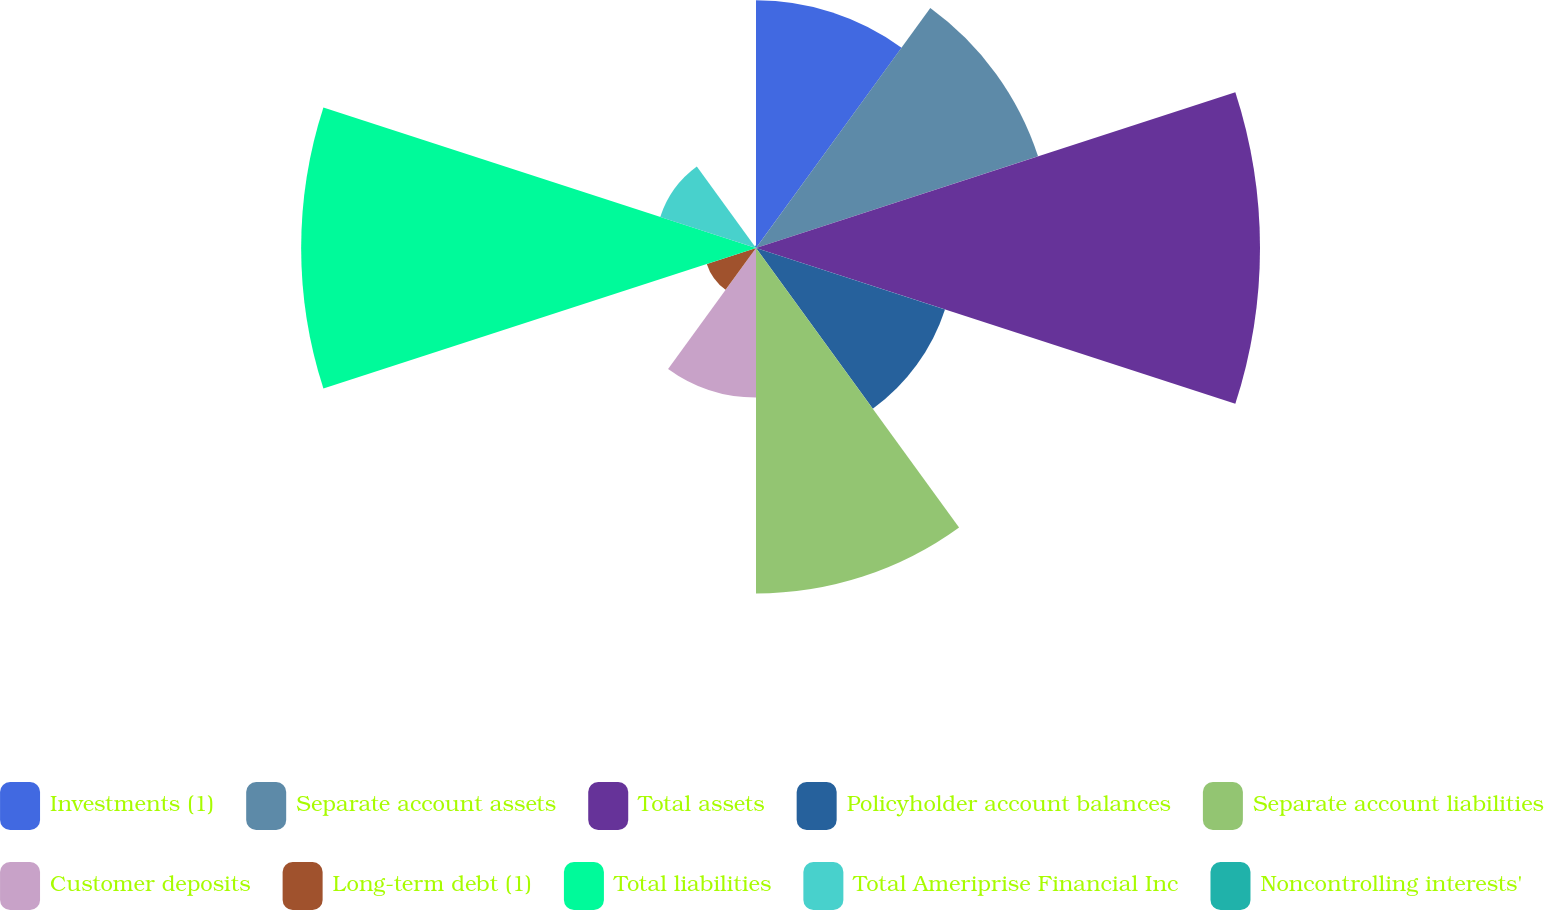<chart> <loc_0><loc_0><loc_500><loc_500><pie_chart><fcel>Investments (1)<fcel>Separate account assets<fcel>Total assets<fcel>Policyholder account balances<fcel>Separate account liabilities<fcel>Customer deposits<fcel>Long-term debt (1)<fcel>Total liabilities<fcel>Total Ameriprise Financial Inc<fcel>Noncontrolling interests'<nl><fcel>10.53%<fcel>12.61%<fcel>21.43%<fcel>8.45%<fcel>14.69%<fcel>6.36%<fcel>2.2%<fcel>19.34%<fcel>4.28%<fcel>0.11%<nl></chart> 